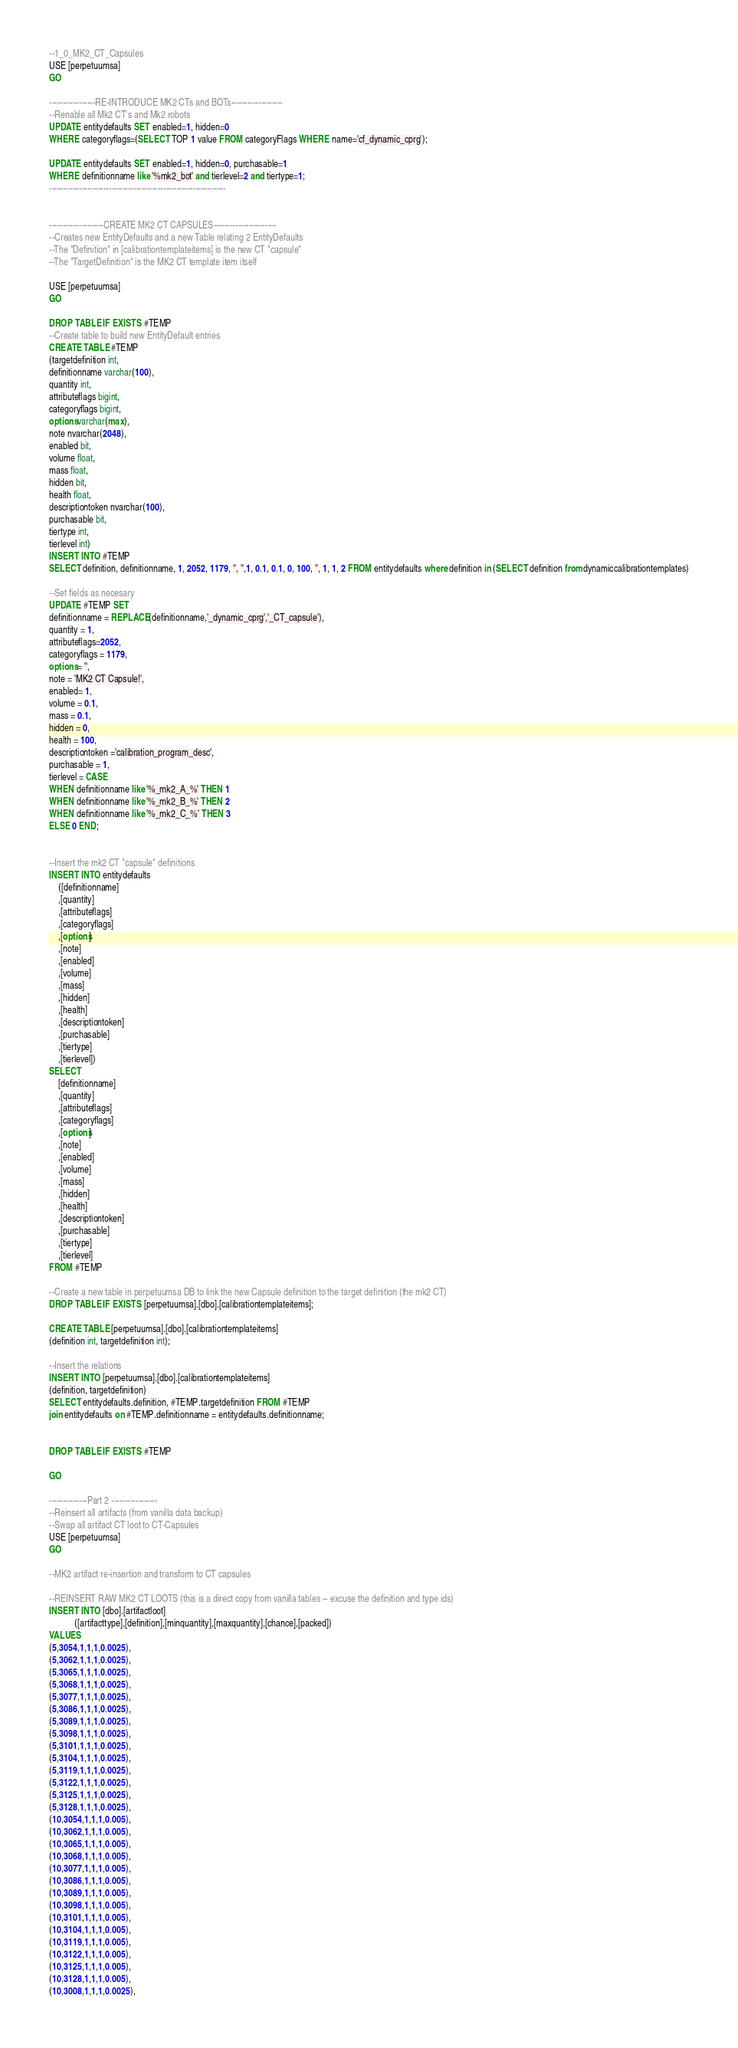Convert code to text. <code><loc_0><loc_0><loc_500><loc_500><_SQL_>

--1_0_MK2_CT_Capsules
USE [perpetuumsa]
GO

-----------------RE-INTRODUCE MK2 CTs and BOTs-------------------
--Renable all Mk2 CT's and Mk2 robots
UPDATE entitydefaults SET enabled=1, hidden=0
WHERE categoryflags=(SELECT TOP 1 value FROM categoryFlags WHERE name='cf_dynamic_cprg');

UPDATE entitydefaults SET enabled=1, hidden=0, purchasable=1
WHERE definitionname like '%mk2_bot' and tierlevel=2 and tiertype=1;
-----------------------------------------------------------------


--------------------CREATE MK2 CT CAPSULES-----------------------
--Creates new EntityDefaults and a new Table relating 2 EntityDefaults
--The "Definition" in [calibrationtemplateitems] is the new CT "capsule"
--The "TargetDefinition" is the MK2 CT template item itself

USE [perpetuumsa]
GO

DROP TABLE IF EXISTS #TEMP
--Create table to build new EntityDefault entries
CREATE TABLE #TEMP  
(targetdefinition int, 
definitionname varchar(100), 
quantity int,
attributeflags bigint,
categoryflags bigint,
options varchar(max),
note nvarchar(2048),
enabled bit,
volume float,
mass float,
hidden bit,
health float,
descriptiontoken nvarchar(100),
purchasable bit,
tiertype int,
tierlevel int)
INSERT INTO #TEMP 
SELECT definition, definitionname, 1, 2052, 1179, '', '',1, 0.1, 0.1, 0, 100, '', 1, 1, 2 FROM entitydefaults where definition in (SELECT definition from dynamiccalibrationtemplates)

--Set fields as necesary
UPDATE #TEMP SET
definitionname = REPLACE(definitionname,'_dynamic_cprg','_CT_capsule'),
quantity = 1,
attributeflags=2052,
categoryflags = 1179,
options = '',
note = 'MK2 CT Capsule!',
enabled= 1,
volume = 0.1,
mass = 0.1,
hidden = 0,
health = 100,
descriptiontoken ='calibration_program_desc',
purchasable = 1,
tierlevel = CASE 
WHEN definitionname like '%_mk2_A_%' THEN 1
WHEN definitionname like '%_mk2_B_%' THEN 2
WHEN definitionname like '%_mk2_C_%' THEN 3 
ELSE 0 END;


--Insert the mk2 CT "capsule" definitions
INSERT INTO entitydefaults 
	([definitionname]
	,[quantity]
	,[attributeflags]
	,[categoryflags]
	,[options]
	,[note]
	,[enabled]
	,[volume]
	,[mass]
	,[hidden]
	,[health]
	,[descriptiontoken]
	,[purchasable]
	,[tiertype]
	,[tierlevel])
SELECT 
	[definitionname]
	,[quantity]
	,[attributeflags]
	,[categoryflags]
	,[options]
	,[note]
	,[enabled]
	,[volume]
	,[mass]
	,[hidden]
	,[health]
	,[descriptiontoken]
	,[purchasable]
	,[tiertype]
	,[tierlevel]
FROM #TEMP

--Create a new table in perpetuumsa DB to link the new Capsule definition to the target definition (the mk2 CT)
DROP TABLE IF EXISTS [perpetuumsa].[dbo].[calibrationtemplateitems];

CREATE TABLE [perpetuumsa].[dbo].[calibrationtemplateitems]
(definition int, targetdefinition int);

--Insert the relations
INSERT INTO [perpetuumsa].[dbo].[calibrationtemplateitems]
(definition, targetdefinition)
SELECT entitydefaults.definition, #TEMP.targetdefinition FROM #TEMP 
join entitydefaults on #TEMP.definitionname = entitydefaults.definitionname;


DROP TABLE IF EXISTS #TEMP

GO

--------------Part 2 -----------------
--Reinsert all artifacts (from vanilla data backup)
--Swap all artifact CT loot to CT-Capsules
USE [perpetuumsa]
GO

--MK2 artifact re-insertion and transform to CT capsules

--REINSERT RAW MK2 CT LOOTS (this is a direct copy from vanilla tables -- excuse the definition and type ids)
INSERT INTO [dbo].[artifactloot]
           ([artifacttype],[definition],[minquantity],[maxquantity],[chance],[packed])
VALUES
(5,3054,1,1,1,0.0025),
(5,3062,1,1,1,0.0025),
(5,3065,1,1,1,0.0025),
(5,3068,1,1,1,0.0025),
(5,3077,1,1,1,0.0025),
(5,3086,1,1,1,0.0025),
(5,3089,1,1,1,0.0025),
(5,3098,1,1,1,0.0025),
(5,3101,1,1,1,0.0025),
(5,3104,1,1,1,0.0025),
(5,3119,1,1,1,0.0025),
(5,3122,1,1,1,0.0025),
(5,3125,1,1,1,0.0025),
(5,3128,1,1,1,0.0025),
(10,3054,1,1,1,0.005),
(10,3062,1,1,1,0.005),
(10,3065,1,1,1,0.005),
(10,3068,1,1,1,0.005),
(10,3077,1,1,1,0.005),
(10,3086,1,1,1,0.005),
(10,3089,1,1,1,0.005),
(10,3098,1,1,1,0.005),
(10,3101,1,1,1,0.005),
(10,3104,1,1,1,0.005),
(10,3119,1,1,1,0.005),
(10,3122,1,1,1,0.005),
(10,3125,1,1,1,0.005),
(10,3128,1,1,1,0.005),
(10,3008,1,1,1,0.0025),</code> 